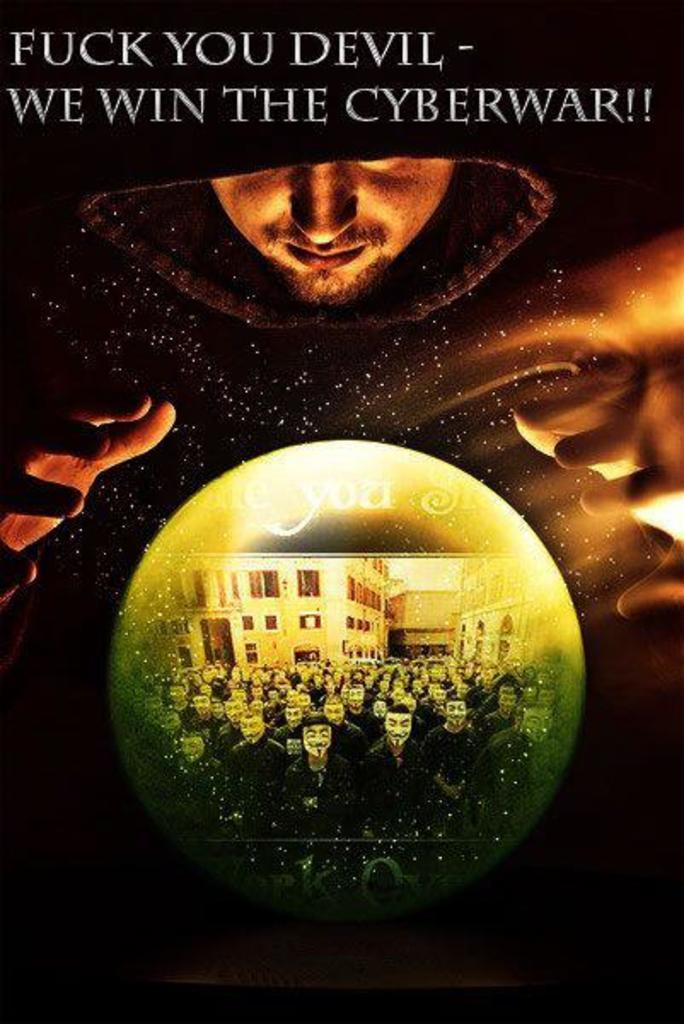<image>
Summarize the visual content of the image. A person looking over a crystal ball that has a title that says We win the Cyberwar above the person 